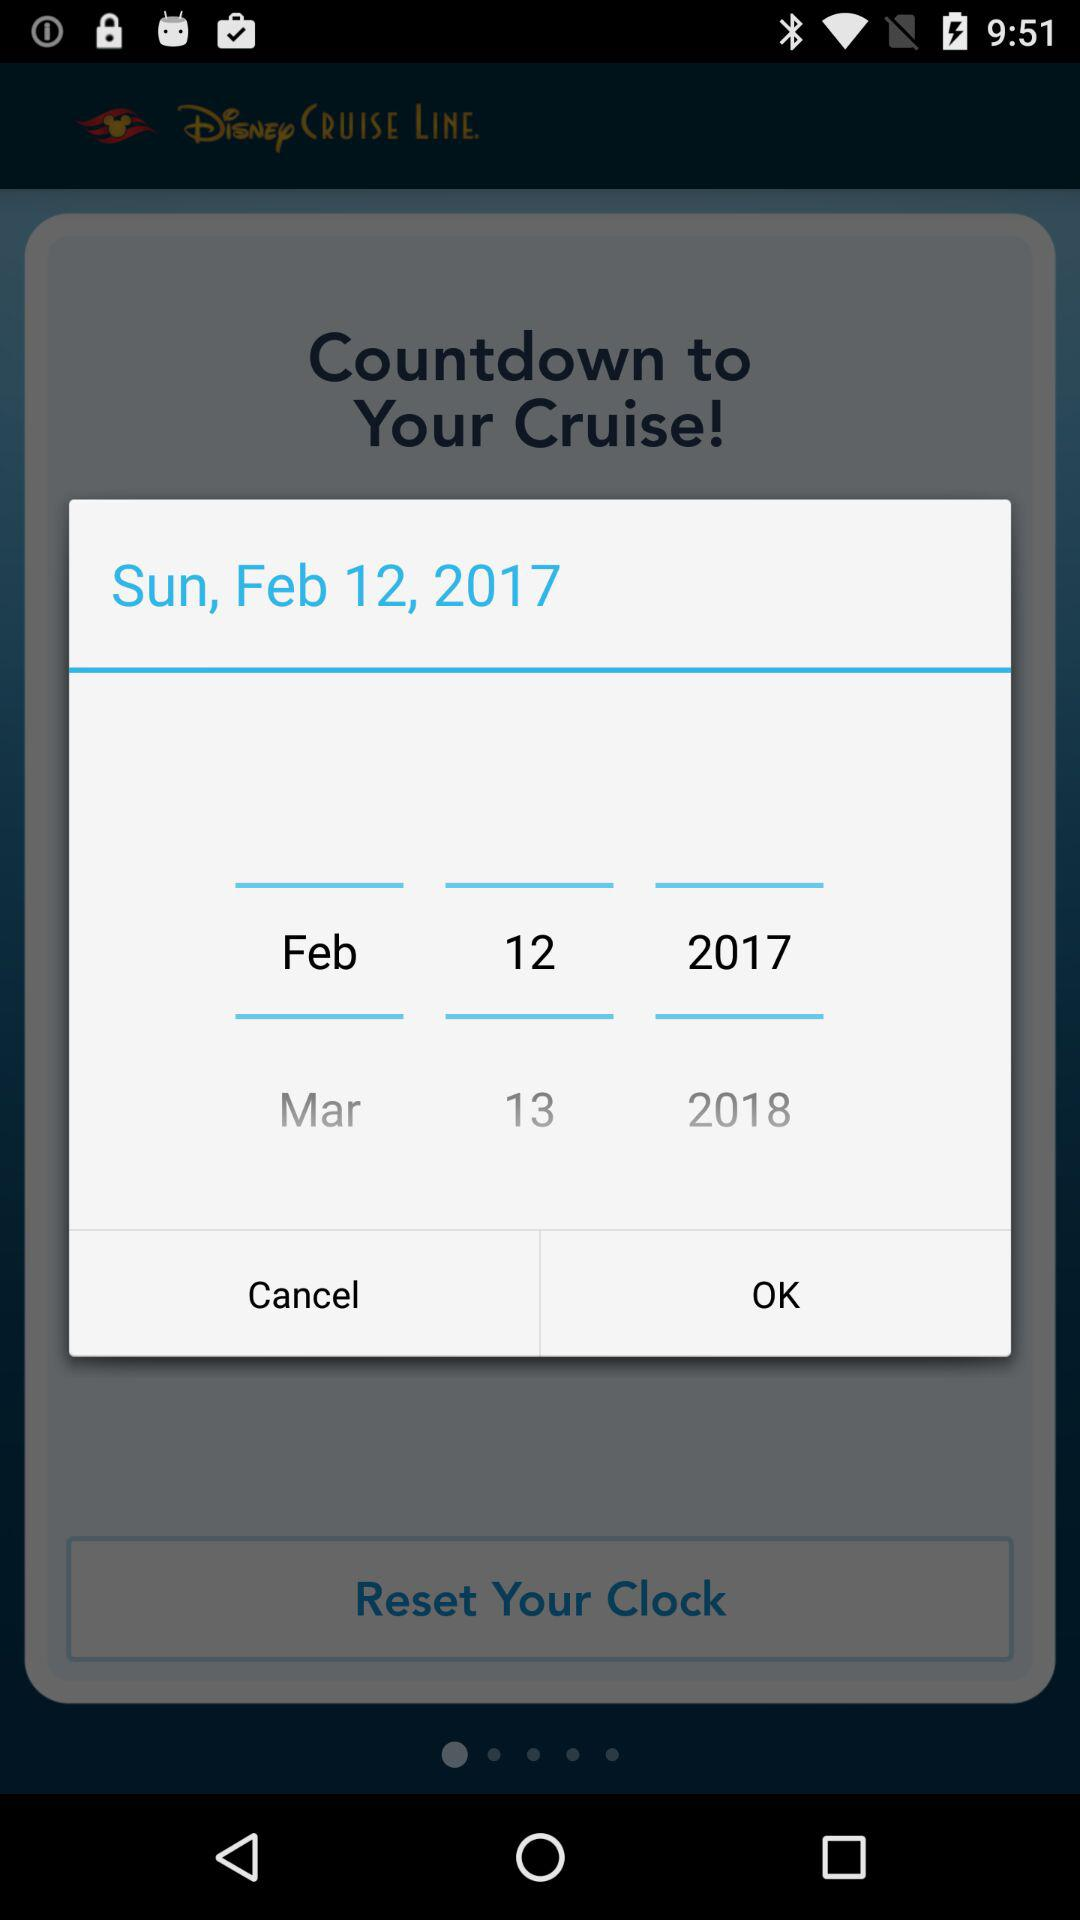What are we resetting our clock to?
When the provided information is insufficient, respond with <no answer>. <no answer> 